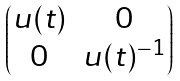<formula> <loc_0><loc_0><loc_500><loc_500>\begin{pmatrix} u ( t ) & 0 \\ 0 & u ( t ) ^ { - 1 } \end{pmatrix}</formula> 